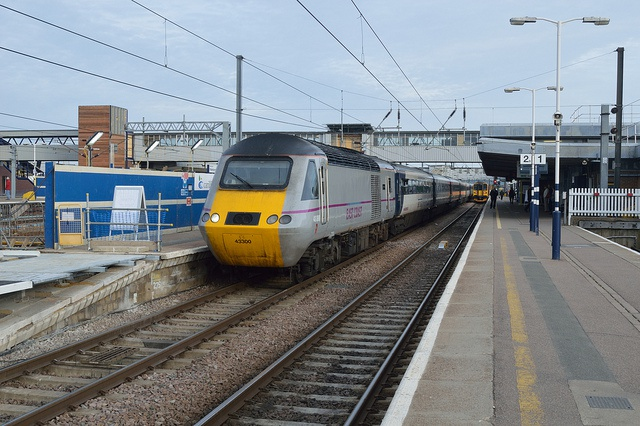Describe the objects in this image and their specific colors. I can see train in lightblue, black, gray, darkgray, and orange tones, people in lightblue, black, and purple tones, people in black and lightblue tones, people in lightblue, black, gray, and maroon tones, and people in black and lightblue tones in this image. 